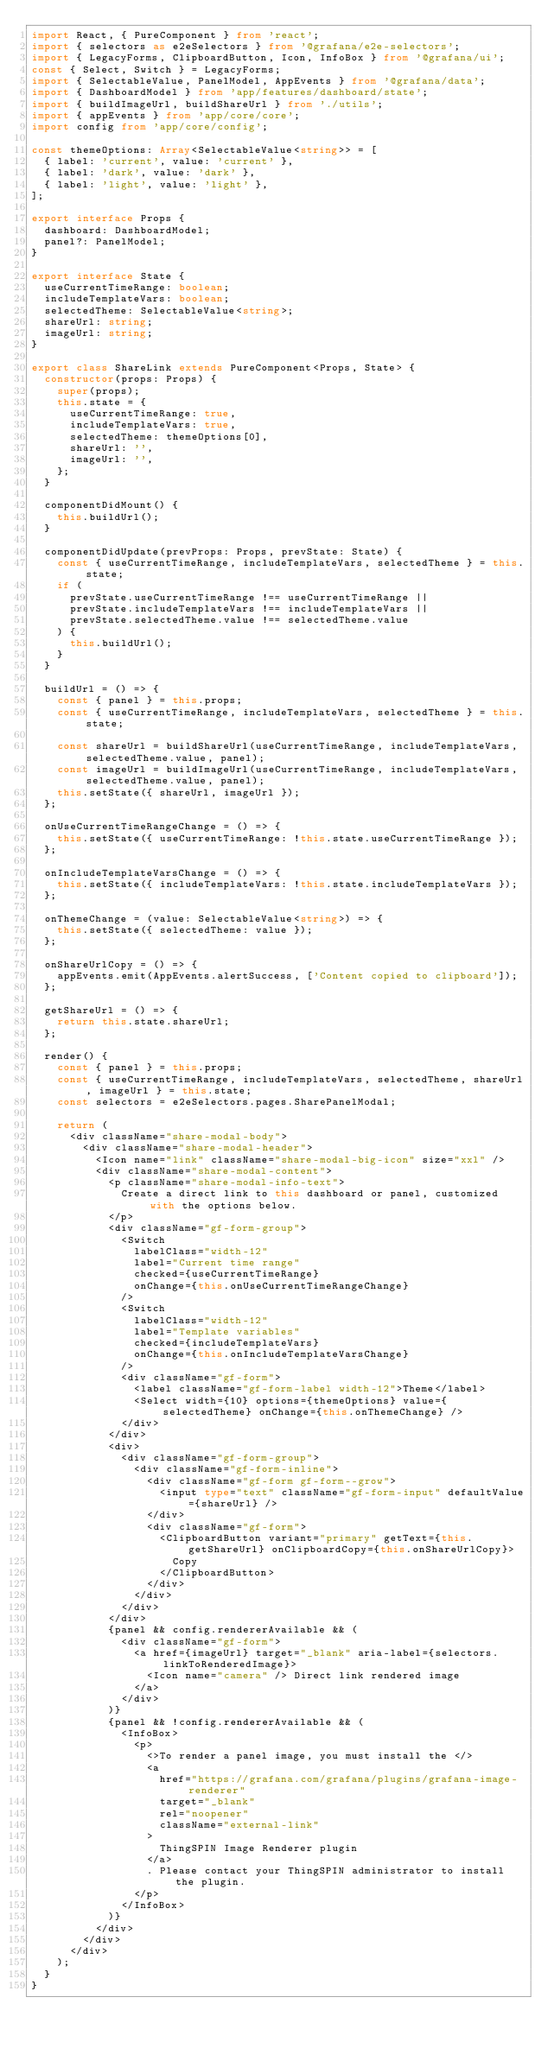Convert code to text. <code><loc_0><loc_0><loc_500><loc_500><_TypeScript_>import React, { PureComponent } from 'react';
import { selectors as e2eSelectors } from '@grafana/e2e-selectors';
import { LegacyForms, ClipboardButton, Icon, InfoBox } from '@grafana/ui';
const { Select, Switch } = LegacyForms;
import { SelectableValue, PanelModel, AppEvents } from '@grafana/data';
import { DashboardModel } from 'app/features/dashboard/state';
import { buildImageUrl, buildShareUrl } from './utils';
import { appEvents } from 'app/core/core';
import config from 'app/core/config';

const themeOptions: Array<SelectableValue<string>> = [
  { label: 'current', value: 'current' },
  { label: 'dark', value: 'dark' },
  { label: 'light', value: 'light' },
];

export interface Props {
  dashboard: DashboardModel;
  panel?: PanelModel;
}

export interface State {
  useCurrentTimeRange: boolean;
  includeTemplateVars: boolean;
  selectedTheme: SelectableValue<string>;
  shareUrl: string;
  imageUrl: string;
}

export class ShareLink extends PureComponent<Props, State> {
  constructor(props: Props) {
    super(props);
    this.state = {
      useCurrentTimeRange: true,
      includeTemplateVars: true,
      selectedTheme: themeOptions[0],
      shareUrl: '',
      imageUrl: '',
    };
  }

  componentDidMount() {
    this.buildUrl();
  }

  componentDidUpdate(prevProps: Props, prevState: State) {
    const { useCurrentTimeRange, includeTemplateVars, selectedTheme } = this.state;
    if (
      prevState.useCurrentTimeRange !== useCurrentTimeRange ||
      prevState.includeTemplateVars !== includeTemplateVars ||
      prevState.selectedTheme.value !== selectedTheme.value
    ) {
      this.buildUrl();
    }
  }

  buildUrl = () => {
    const { panel } = this.props;
    const { useCurrentTimeRange, includeTemplateVars, selectedTheme } = this.state;

    const shareUrl = buildShareUrl(useCurrentTimeRange, includeTemplateVars, selectedTheme.value, panel);
    const imageUrl = buildImageUrl(useCurrentTimeRange, includeTemplateVars, selectedTheme.value, panel);
    this.setState({ shareUrl, imageUrl });
  };

  onUseCurrentTimeRangeChange = () => {
    this.setState({ useCurrentTimeRange: !this.state.useCurrentTimeRange });
  };

  onIncludeTemplateVarsChange = () => {
    this.setState({ includeTemplateVars: !this.state.includeTemplateVars });
  };

  onThemeChange = (value: SelectableValue<string>) => {
    this.setState({ selectedTheme: value });
  };

  onShareUrlCopy = () => {
    appEvents.emit(AppEvents.alertSuccess, ['Content copied to clipboard']);
  };

  getShareUrl = () => {
    return this.state.shareUrl;
  };

  render() {
    const { panel } = this.props;
    const { useCurrentTimeRange, includeTemplateVars, selectedTheme, shareUrl, imageUrl } = this.state;
    const selectors = e2eSelectors.pages.SharePanelModal;

    return (
      <div className="share-modal-body">
        <div className="share-modal-header">
          <Icon name="link" className="share-modal-big-icon" size="xxl" />
          <div className="share-modal-content">
            <p className="share-modal-info-text">
              Create a direct link to this dashboard or panel, customized with the options below.
            </p>
            <div className="gf-form-group">
              <Switch
                labelClass="width-12"
                label="Current time range"
                checked={useCurrentTimeRange}
                onChange={this.onUseCurrentTimeRangeChange}
              />
              <Switch
                labelClass="width-12"
                label="Template variables"
                checked={includeTemplateVars}
                onChange={this.onIncludeTemplateVarsChange}
              />
              <div className="gf-form">
                <label className="gf-form-label width-12">Theme</label>
                <Select width={10} options={themeOptions} value={selectedTheme} onChange={this.onThemeChange} />
              </div>
            </div>
            <div>
              <div className="gf-form-group">
                <div className="gf-form-inline">
                  <div className="gf-form gf-form--grow">
                    <input type="text" className="gf-form-input" defaultValue={shareUrl} />
                  </div>
                  <div className="gf-form">
                    <ClipboardButton variant="primary" getText={this.getShareUrl} onClipboardCopy={this.onShareUrlCopy}>
                      Copy
                    </ClipboardButton>
                  </div>
                </div>
              </div>
            </div>
            {panel && config.rendererAvailable && (
              <div className="gf-form">
                <a href={imageUrl} target="_blank" aria-label={selectors.linkToRenderedImage}>
                  <Icon name="camera" /> Direct link rendered image
                </a>
              </div>
            )}
            {panel && !config.rendererAvailable && (
              <InfoBox>
                <p>
                  <>To render a panel image, you must install the </>
                  <a
                    href="https://grafana.com/grafana/plugins/grafana-image-renderer"
                    target="_blank"
                    rel="noopener"
                    className="external-link"
                  >
                    ThingSPIN Image Renderer plugin
                  </a>
                  . Please contact your ThingSPIN administrator to install the plugin.
                </p>
              </InfoBox>
            )}
          </div>
        </div>
      </div>
    );
  }
}
</code> 